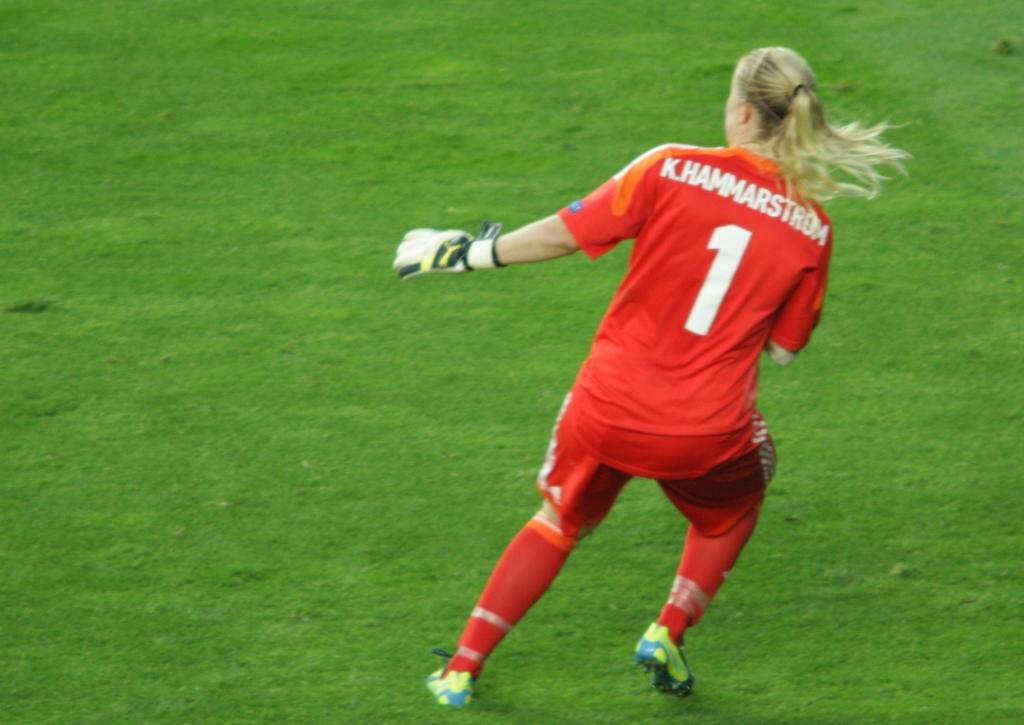Provide a one-sentence caption for the provided image. Soccer goalie with number one on the back in white on an orange jersey. 